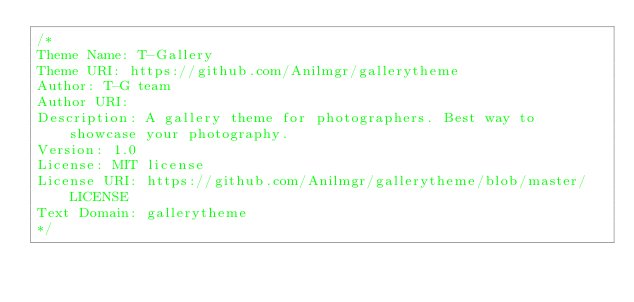Convert code to text. <code><loc_0><loc_0><loc_500><loc_500><_CSS_>/*
Theme Name: T-Gallery  
Theme URI: https://github.com/Anilmgr/gallerytheme
Author: T-G team
Author URI: 
Description: A gallery theme for photographers. Best way to showcase your photography.
Version: 1.0
License: MIT license
License URI: https://github.com/Anilmgr/gallerytheme/blob/master/LICENSE
Text Domain: gallerytheme
*/</code> 